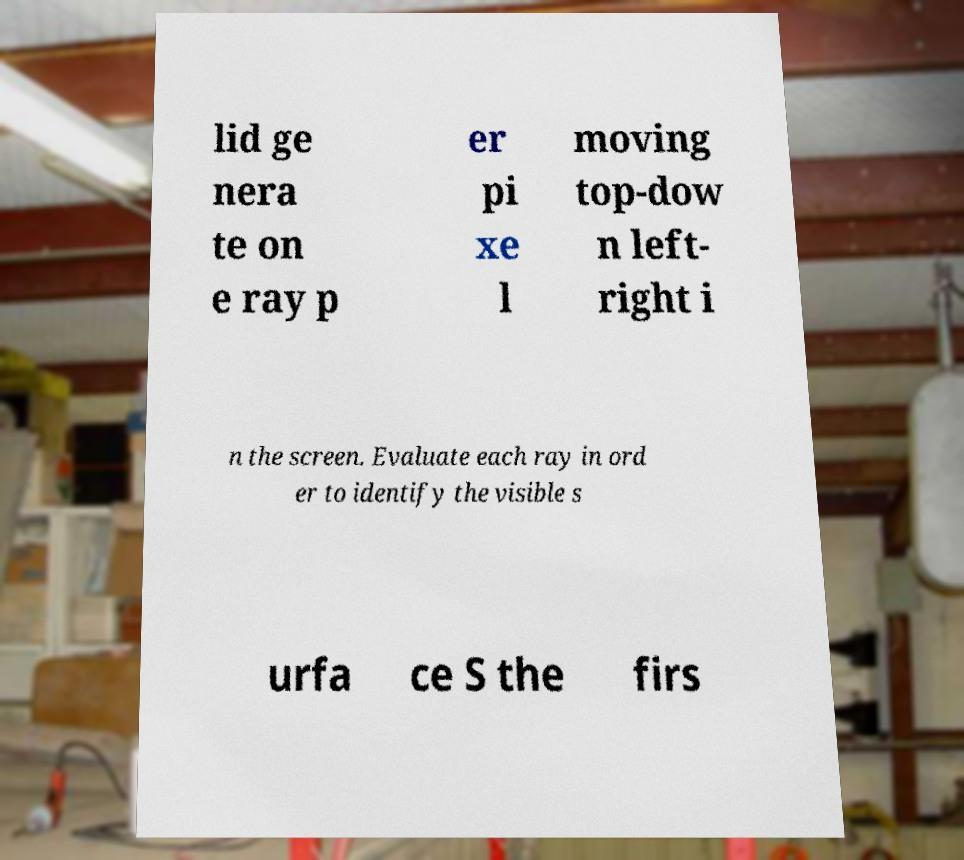Can you accurately transcribe the text from the provided image for me? lid ge nera te on e ray p er pi xe l moving top-dow n left- right i n the screen. Evaluate each ray in ord er to identify the visible s urfa ce S the firs 